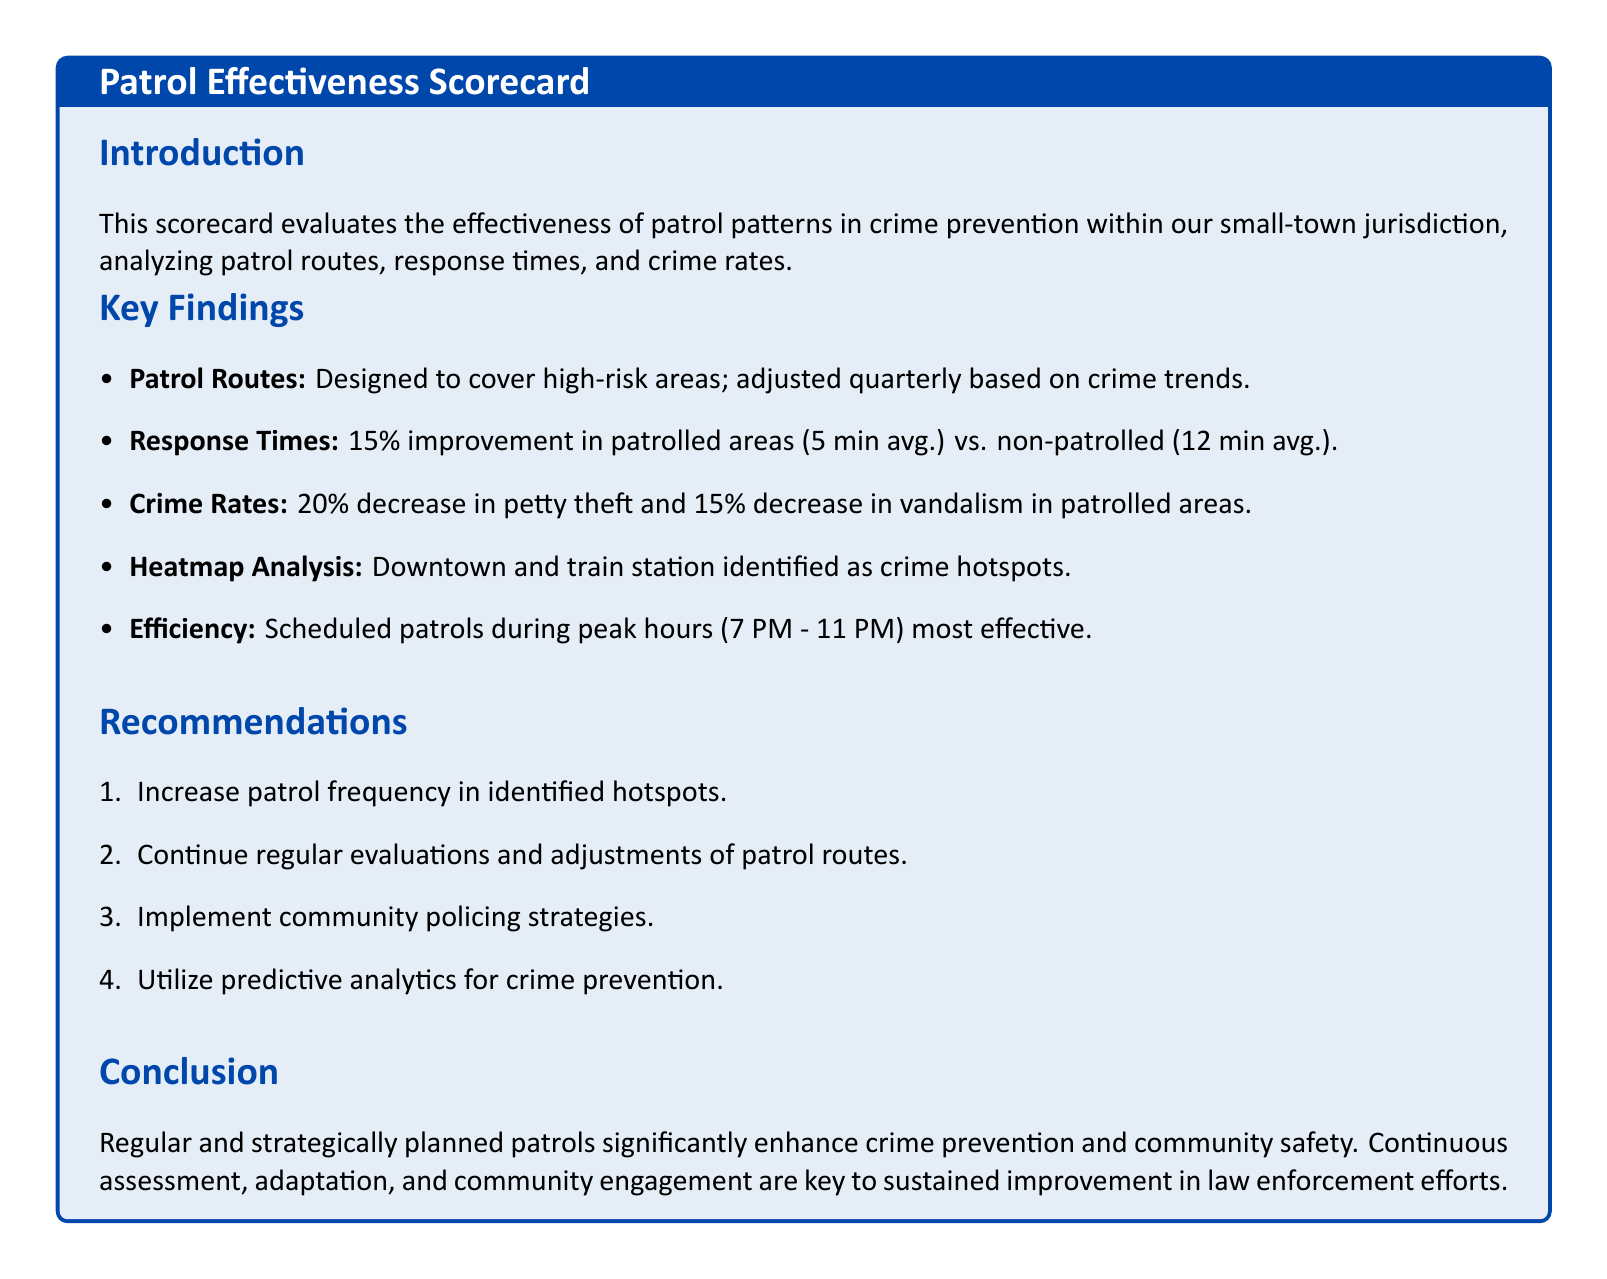what is the percentage improvement in response times for patrolled areas? The document states there is a 15% improvement in response times for patrolled areas compared to non-patrolled areas.
Answer: 15% what is the average response time in patrolled areas? According to the findings, the average response time in patrolled areas is 5 minutes.
Answer: 5 minutes which areas are identified as crime hotspots in the heatmap analysis? The heatmap analysis points to downtown and the train station as the identified crime hotspots.
Answer: downtown and train station by what percentage did petty theft decrease in patrolled areas? The document mentions a 20% decrease in petty theft within patrolled areas.
Answer: 20% what time frame is mentioned as being the most effective for scheduled patrols? The report highlights that patrols during the peak hours of 7 PM to 11 PM are most effective.
Answer: 7 PM - 11 PM how much did vandalism decrease in patrolled areas? The report indicates a 15% decrease in vandalism in areas with patrols.
Answer: 15% what is recommended to increase patrol effectiveness? The recommendations suggest increasing patrol frequency in identified hotspots to improve effectiveness.
Answer: increase patrol frequency what type of policing strategies are recommended? The scorecard recommends implementing community policing strategies to enhance effectiveness.
Answer: community policing strategies how often are patrol routes adjusted? The document specifies that patrol routes are adjusted quarterly based on crime trends.
Answer: quarterly 